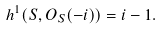<formula> <loc_0><loc_0><loc_500><loc_500>h ^ { 1 } ( S , O _ { S } ( - i ) ) = i - 1 .</formula> 